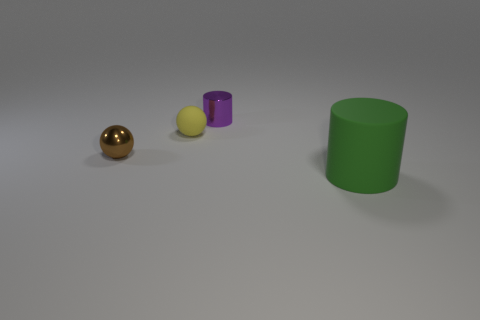Add 2 purple objects. How many objects exist? 6 Add 1 small brown shiny objects. How many small brown shiny objects are left? 2 Add 1 large blue things. How many large blue things exist? 1 Subtract 0 red spheres. How many objects are left? 4 Subtract all small green metal cubes. Subtract all purple metallic cylinders. How many objects are left? 3 